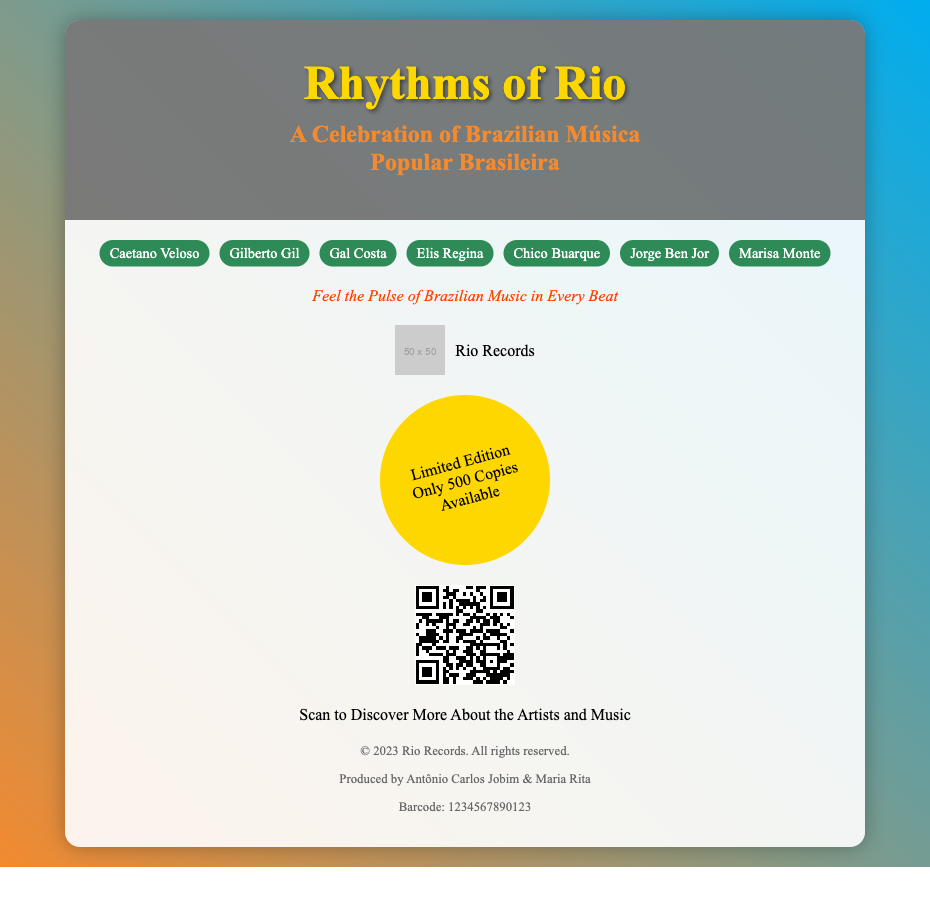What is the title of the album? The title of the album is displayed prominently at the top of the document.
Answer: Rhythms of Rio Who are the featured artists? The document lists several iconic Brazilian artists in the "artists" section.
Answer: Caetano Veloso, Gilberto Gil, Gal Costa, Elis Regina, Chico Buarque, Jorge Ben Jor, Marisa Monte How many copies of the album are available? The document states the number of copies available in the "limited edition" section.
Answer: Only 500 Copies Available What is the tagline of the album? The tagline is presented below the artist names, summarizing the album's essence.
Answer: Feel the Pulse of Brazilian Music in Every Beat What is the label name? The label name is displayed alongside a logo in the provided section.
Answer: Rio Records Who produced the album? The producers are named in the legal section of the document.
Answer: Antônio Carlos Jobim & Maria Rita What is the primary color of the artists' labels? The background color of the artist labels is specifically stated in the document.
Answer: #2E8B57 (Green) What does the QR code do? The purpose of the QR code is stated beneath the code image in the document.
Answer: Discover More About the Artists and Music What is the size of the QR code in the document? The QR code size is indicated by the dimensions specified in the source link.
Answer: 100x100 